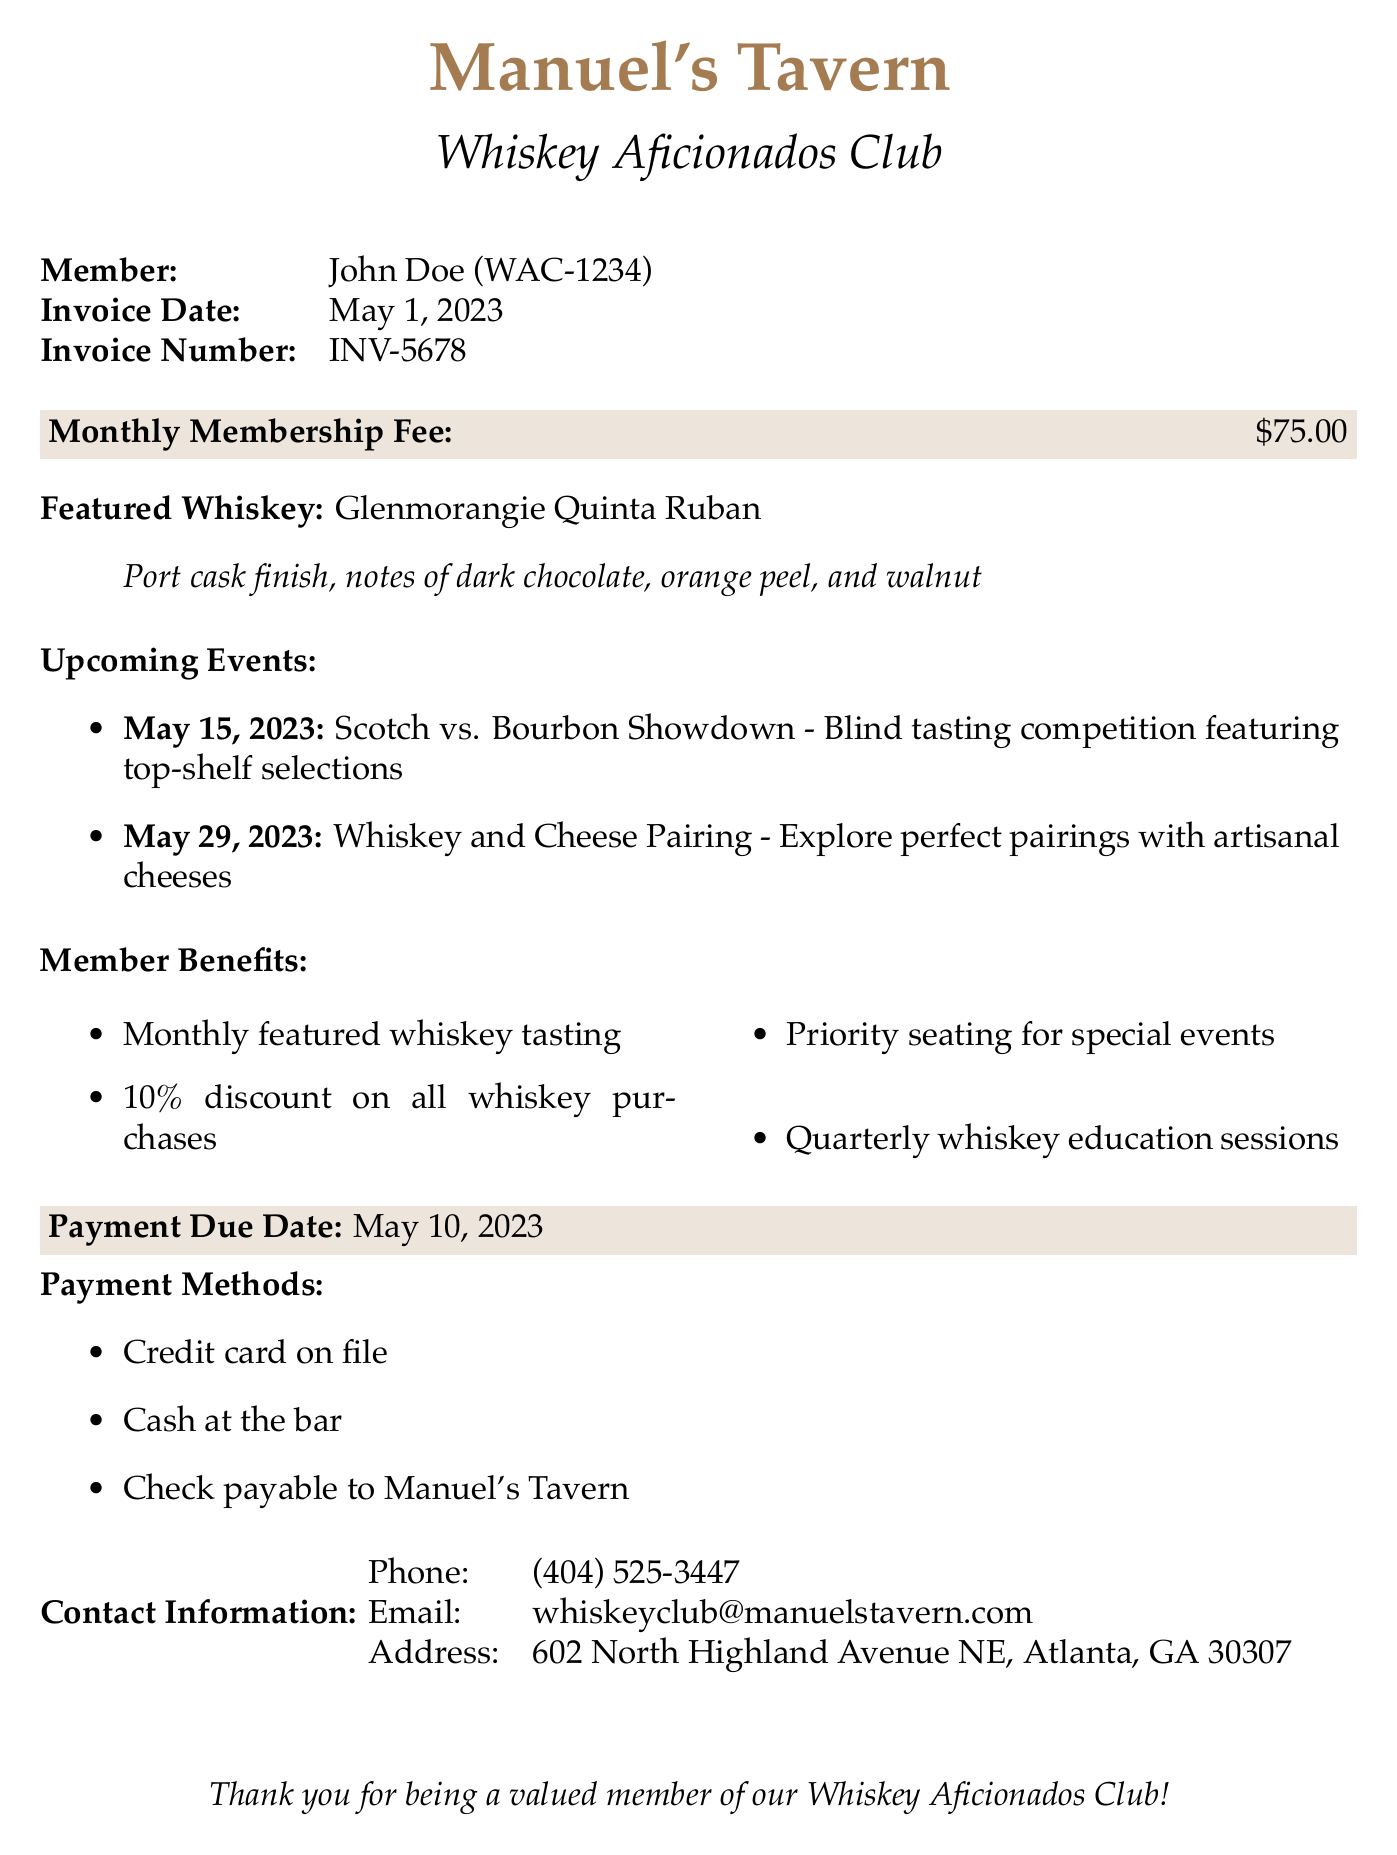What is the member's name? The document specifies the member's name as John Doe.
Answer: John Doe What is the invoice number? The invoice number is clearly stated in the document as INV-5678.
Answer: INV-5678 What is the payment due date? The document mentions that the payment due date is May 10, 2023.
Answer: May 10, 2023 What is the monthly membership fee? The monthly membership fee listed in the document is $75.00.
Answer: $75.00 What is the featured whiskey? The document highlights the featured whiskey as Glenmorangie Quinta Ruban.
Answer: Glenmorangie Quinta Ruban How many upcoming events are listed? There are two upcoming events detailed in the document.
Answer: 2 What percentage discount do members receive on whiskey purchases? The document states that members receive a 10% discount on all whiskey purchases.
Answer: 10% What are the payment methods mentioned? The document lists several payment methods: credit card on file, cash at the bar, and check payable to Manuel's Tavern.
Answer: Credit card on file, cash at the bar, check payable to Manuel's Tavern What is the primary benefit of the Whiskey Aficionados Club? The document specifies that a primary benefit includes monthly featured whiskey tasting.
Answer: Monthly featured whiskey tasting 